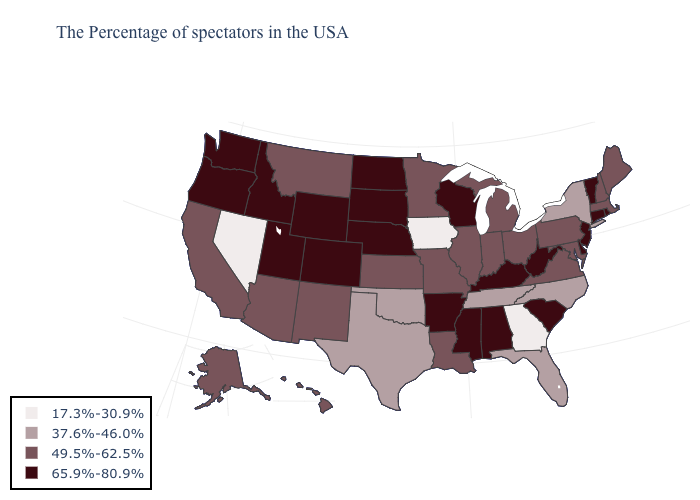Which states have the lowest value in the Northeast?
Quick response, please. New York. Is the legend a continuous bar?
Give a very brief answer. No. What is the value of North Dakota?
Answer briefly. 65.9%-80.9%. Which states have the highest value in the USA?
Write a very short answer. Rhode Island, Vermont, Connecticut, New Jersey, Delaware, South Carolina, West Virginia, Kentucky, Alabama, Wisconsin, Mississippi, Arkansas, Nebraska, South Dakota, North Dakota, Wyoming, Colorado, Utah, Idaho, Washington, Oregon. What is the highest value in the USA?
Short answer required. 65.9%-80.9%. What is the value of Illinois?
Quick response, please. 49.5%-62.5%. Does Louisiana have the same value as West Virginia?
Quick response, please. No. Does Ohio have the highest value in the MidWest?
Concise answer only. No. Name the states that have a value in the range 65.9%-80.9%?
Keep it brief. Rhode Island, Vermont, Connecticut, New Jersey, Delaware, South Carolina, West Virginia, Kentucky, Alabama, Wisconsin, Mississippi, Arkansas, Nebraska, South Dakota, North Dakota, Wyoming, Colorado, Utah, Idaho, Washington, Oregon. Does Georgia have the lowest value in the USA?
Quick response, please. Yes. What is the value of Missouri?
Be succinct. 49.5%-62.5%. What is the lowest value in states that border Texas?
Quick response, please. 37.6%-46.0%. What is the highest value in the Northeast ?
Quick response, please. 65.9%-80.9%. What is the value of Georgia?
Concise answer only. 17.3%-30.9%. 